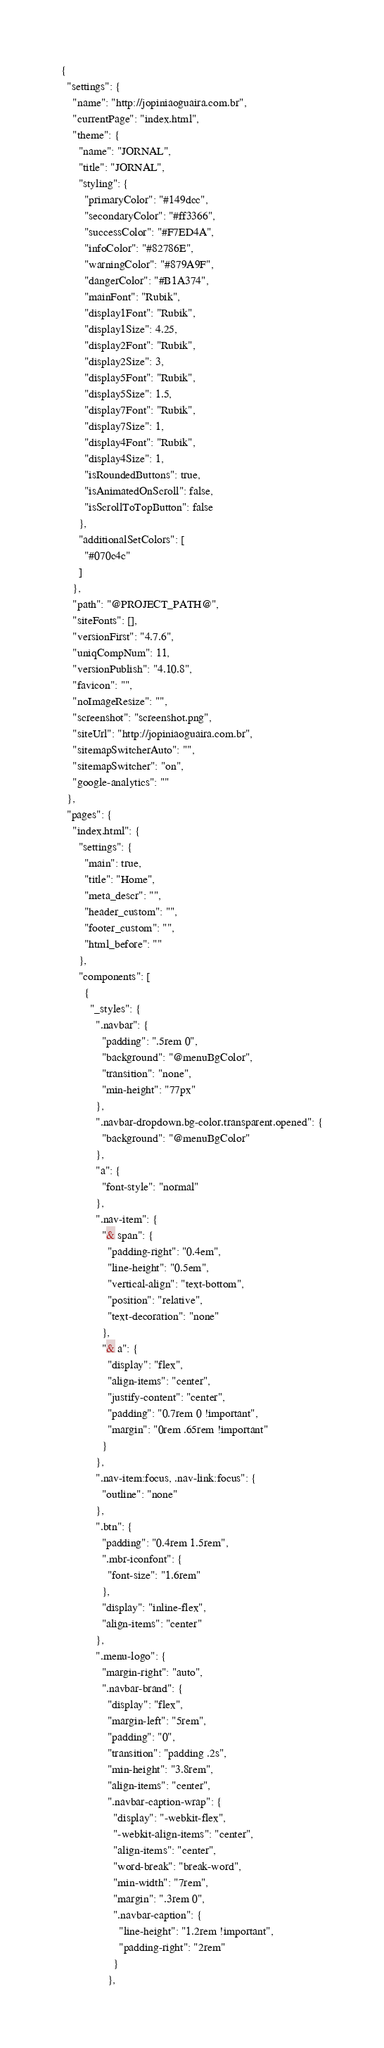Convert code to text. <code><loc_0><loc_0><loc_500><loc_500><_HTML_>{
  "settings": {
    "name": "http://jopiniaoguaira.com.br",
    "currentPage": "index.html",
    "theme": {
      "name": "JORNAL",
      "title": "JORNAL",
      "styling": {
        "primaryColor": "#149dcc",
        "secondaryColor": "#ff3366",
        "successColor": "#F7ED4A",
        "infoColor": "#82786E",
        "warningColor": "#879A9F",
        "dangerColor": "#B1A374",
        "mainFont": "Rubik",
        "display1Font": "Rubik",
        "display1Size": 4.25,
        "display2Font": "Rubik",
        "display2Size": 3,
        "display5Font": "Rubik",
        "display5Size": 1.5,
        "display7Font": "Rubik",
        "display7Size": 1,
        "display4Font": "Rubik",
        "display4Size": 1,
        "isRoundedButtons": true,
        "isAnimatedOnScroll": false,
        "isScrollToTopButton": false
      },
      "additionalSetColors": [
        "#070c4c"
      ]
    },
    "path": "@PROJECT_PATH@",
    "siteFonts": [],
    "versionFirst": "4.7.6",
    "uniqCompNum": 11,
    "versionPublish": "4.10.8",
    "favicon": "",
    "noImageResize": "",
    "screenshot": "screenshot.png",
    "siteUrl": "http://jopiniaoguaira.com.br",
    "sitemapSwitcherAuto": "",
    "sitemapSwitcher": "on",
    "google-analytics": ""
  },
  "pages": {
    "index.html": {
      "settings": {
        "main": true,
        "title": "Home",
        "meta_descr": "",
        "header_custom": "",
        "footer_custom": "",
        "html_before": ""
      },
      "components": [
        {
          "_styles": {
            ".navbar": {
              "padding": ".5rem 0",
              "background": "@menuBgColor",
              "transition": "none",
              "min-height": "77px"
            },
            ".navbar-dropdown.bg-color.transparent.opened": {
              "background": "@menuBgColor"
            },
            "a": {
              "font-style": "normal"
            },
            ".nav-item": {
              "& span": {
                "padding-right": "0.4em",
                "line-height": "0.5em",
                "vertical-align": "text-bottom",
                "position": "relative",
                "text-decoration": "none"
              },
              "& a": {
                "display": "flex",
                "align-items": "center",
                "justify-content": "center",
                "padding": "0.7rem 0 !important",
                "margin": "0rem .65rem !important"
              }
            },
            ".nav-item:focus, .nav-link:focus": {
              "outline": "none"
            },
            ".btn": {
              "padding": "0.4rem 1.5rem",
              ".mbr-iconfont": {
                "font-size": "1.6rem"
              },
              "display": "inline-flex",
              "align-items": "center"
            },
            ".menu-logo": {
              "margin-right": "auto",
              ".navbar-brand": {
                "display": "flex",
                "margin-left": "5rem",
                "padding": "0",
                "transition": "padding .2s",
                "min-height": "3.8rem",
                "align-items": "center",
                ".navbar-caption-wrap": {
                  "display": "-webkit-flex",
                  "-webkit-align-items": "center",
                  "align-items": "center",
                  "word-break": "break-word",
                  "min-width": "7rem",
                  "margin": ".3rem 0",
                  ".navbar-caption": {
                    "line-height": "1.2rem !important",
                    "padding-right": "2rem"
                  }
                },</code> 